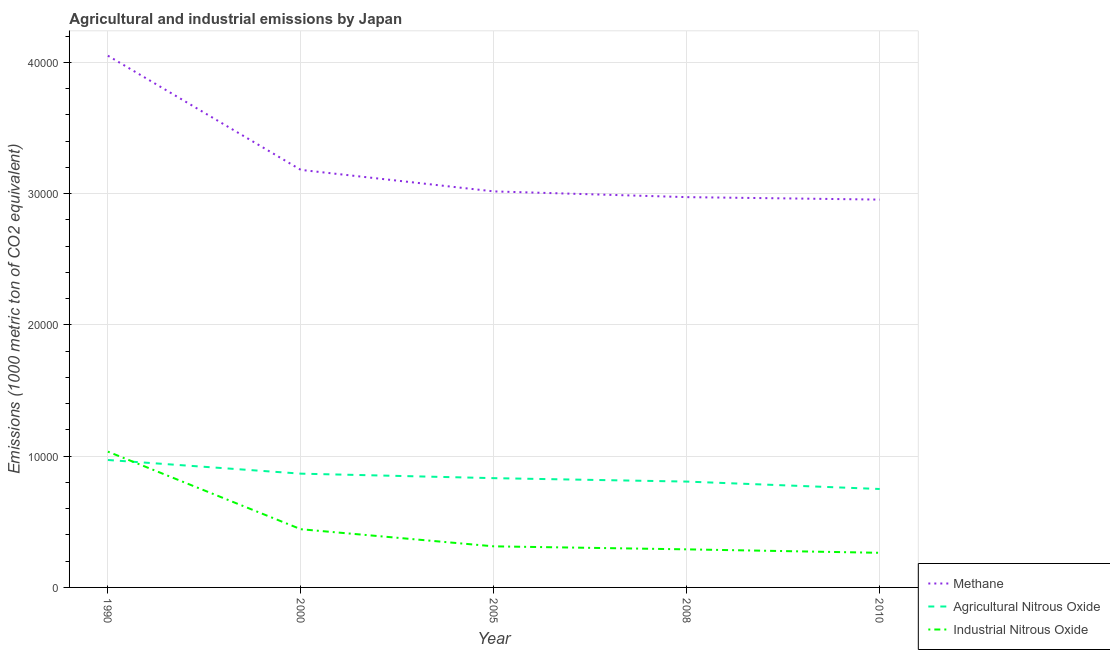How many different coloured lines are there?
Keep it short and to the point. 3. Is the number of lines equal to the number of legend labels?
Offer a very short reply. Yes. What is the amount of industrial nitrous oxide emissions in 2000?
Give a very brief answer. 4433.9. Across all years, what is the maximum amount of industrial nitrous oxide emissions?
Offer a very short reply. 1.03e+04. Across all years, what is the minimum amount of methane emissions?
Offer a terse response. 2.95e+04. In which year was the amount of industrial nitrous oxide emissions maximum?
Your answer should be very brief. 1990. In which year was the amount of industrial nitrous oxide emissions minimum?
Offer a terse response. 2010. What is the total amount of industrial nitrous oxide emissions in the graph?
Provide a short and direct response. 2.34e+04. What is the difference between the amount of agricultural nitrous oxide emissions in 2000 and that in 2008?
Your answer should be very brief. 603.5. What is the difference between the amount of industrial nitrous oxide emissions in 2010 and the amount of agricultural nitrous oxide emissions in 2005?
Ensure brevity in your answer.  -5687. What is the average amount of agricultural nitrous oxide emissions per year?
Give a very brief answer. 8452.46. In the year 2005, what is the difference between the amount of agricultural nitrous oxide emissions and amount of industrial nitrous oxide emissions?
Your response must be concise. 5194.4. In how many years, is the amount of agricultural nitrous oxide emissions greater than 14000 metric ton?
Provide a succinct answer. 0. What is the ratio of the amount of industrial nitrous oxide emissions in 1990 to that in 2000?
Offer a terse response. 2.33. Is the amount of agricultural nitrous oxide emissions in 1990 less than that in 2000?
Your answer should be compact. No. Is the difference between the amount of industrial nitrous oxide emissions in 2000 and 2010 greater than the difference between the amount of agricultural nitrous oxide emissions in 2000 and 2010?
Your answer should be very brief. Yes. What is the difference between the highest and the second highest amount of industrial nitrous oxide emissions?
Give a very brief answer. 5911.5. What is the difference between the highest and the lowest amount of industrial nitrous oxide emissions?
Keep it short and to the point. 7707.7. Is the sum of the amount of agricultural nitrous oxide emissions in 1990 and 2010 greater than the maximum amount of industrial nitrous oxide emissions across all years?
Offer a terse response. Yes. Does the amount of methane emissions monotonically increase over the years?
Give a very brief answer. No. Is the amount of industrial nitrous oxide emissions strictly less than the amount of agricultural nitrous oxide emissions over the years?
Provide a succinct answer. No. How many lines are there?
Offer a very short reply. 3. What is the difference between two consecutive major ticks on the Y-axis?
Keep it short and to the point. 10000. Does the graph contain grids?
Your response must be concise. Yes. Where does the legend appear in the graph?
Your answer should be compact. Bottom right. How many legend labels are there?
Offer a very short reply. 3. What is the title of the graph?
Provide a succinct answer. Agricultural and industrial emissions by Japan. Does "Spain" appear as one of the legend labels in the graph?
Your answer should be compact. No. What is the label or title of the Y-axis?
Offer a very short reply. Emissions (1000 metric ton of CO2 equivalent). What is the Emissions (1000 metric ton of CO2 equivalent) in Methane in 1990?
Give a very brief answer. 4.05e+04. What is the Emissions (1000 metric ton of CO2 equivalent) of Agricultural Nitrous Oxide in 1990?
Your answer should be very brief. 9708.8. What is the Emissions (1000 metric ton of CO2 equivalent) of Industrial Nitrous Oxide in 1990?
Your answer should be very brief. 1.03e+04. What is the Emissions (1000 metric ton of CO2 equivalent) in Methane in 2000?
Offer a very short reply. 3.18e+04. What is the Emissions (1000 metric ton of CO2 equivalent) in Agricultural Nitrous Oxide in 2000?
Provide a succinct answer. 8667.2. What is the Emissions (1000 metric ton of CO2 equivalent) of Industrial Nitrous Oxide in 2000?
Offer a very short reply. 4433.9. What is the Emissions (1000 metric ton of CO2 equivalent) in Methane in 2005?
Offer a very short reply. 3.02e+04. What is the Emissions (1000 metric ton of CO2 equivalent) in Agricultural Nitrous Oxide in 2005?
Your answer should be compact. 8324.7. What is the Emissions (1000 metric ton of CO2 equivalent) in Industrial Nitrous Oxide in 2005?
Provide a short and direct response. 3130.3. What is the Emissions (1000 metric ton of CO2 equivalent) in Methane in 2008?
Your answer should be compact. 2.97e+04. What is the Emissions (1000 metric ton of CO2 equivalent) of Agricultural Nitrous Oxide in 2008?
Offer a very short reply. 8063.7. What is the Emissions (1000 metric ton of CO2 equivalent) in Industrial Nitrous Oxide in 2008?
Your answer should be very brief. 2901. What is the Emissions (1000 metric ton of CO2 equivalent) in Methane in 2010?
Your response must be concise. 2.95e+04. What is the Emissions (1000 metric ton of CO2 equivalent) in Agricultural Nitrous Oxide in 2010?
Your answer should be very brief. 7497.9. What is the Emissions (1000 metric ton of CO2 equivalent) of Industrial Nitrous Oxide in 2010?
Provide a succinct answer. 2637.7. Across all years, what is the maximum Emissions (1000 metric ton of CO2 equivalent) in Methane?
Provide a short and direct response. 4.05e+04. Across all years, what is the maximum Emissions (1000 metric ton of CO2 equivalent) in Agricultural Nitrous Oxide?
Give a very brief answer. 9708.8. Across all years, what is the maximum Emissions (1000 metric ton of CO2 equivalent) of Industrial Nitrous Oxide?
Offer a terse response. 1.03e+04. Across all years, what is the minimum Emissions (1000 metric ton of CO2 equivalent) of Methane?
Make the answer very short. 2.95e+04. Across all years, what is the minimum Emissions (1000 metric ton of CO2 equivalent) of Agricultural Nitrous Oxide?
Your answer should be very brief. 7497.9. Across all years, what is the minimum Emissions (1000 metric ton of CO2 equivalent) in Industrial Nitrous Oxide?
Your response must be concise. 2637.7. What is the total Emissions (1000 metric ton of CO2 equivalent) in Methane in the graph?
Ensure brevity in your answer.  1.62e+05. What is the total Emissions (1000 metric ton of CO2 equivalent) of Agricultural Nitrous Oxide in the graph?
Your answer should be very brief. 4.23e+04. What is the total Emissions (1000 metric ton of CO2 equivalent) of Industrial Nitrous Oxide in the graph?
Your response must be concise. 2.34e+04. What is the difference between the Emissions (1000 metric ton of CO2 equivalent) in Methane in 1990 and that in 2000?
Your answer should be compact. 8700.7. What is the difference between the Emissions (1000 metric ton of CO2 equivalent) in Agricultural Nitrous Oxide in 1990 and that in 2000?
Ensure brevity in your answer.  1041.6. What is the difference between the Emissions (1000 metric ton of CO2 equivalent) of Industrial Nitrous Oxide in 1990 and that in 2000?
Offer a very short reply. 5911.5. What is the difference between the Emissions (1000 metric ton of CO2 equivalent) of Methane in 1990 and that in 2005?
Provide a short and direct response. 1.03e+04. What is the difference between the Emissions (1000 metric ton of CO2 equivalent) of Agricultural Nitrous Oxide in 1990 and that in 2005?
Your answer should be very brief. 1384.1. What is the difference between the Emissions (1000 metric ton of CO2 equivalent) of Industrial Nitrous Oxide in 1990 and that in 2005?
Ensure brevity in your answer.  7215.1. What is the difference between the Emissions (1000 metric ton of CO2 equivalent) of Methane in 1990 and that in 2008?
Provide a short and direct response. 1.08e+04. What is the difference between the Emissions (1000 metric ton of CO2 equivalent) in Agricultural Nitrous Oxide in 1990 and that in 2008?
Offer a terse response. 1645.1. What is the difference between the Emissions (1000 metric ton of CO2 equivalent) in Industrial Nitrous Oxide in 1990 and that in 2008?
Your response must be concise. 7444.4. What is the difference between the Emissions (1000 metric ton of CO2 equivalent) of Methane in 1990 and that in 2010?
Keep it short and to the point. 1.10e+04. What is the difference between the Emissions (1000 metric ton of CO2 equivalent) of Agricultural Nitrous Oxide in 1990 and that in 2010?
Your answer should be compact. 2210.9. What is the difference between the Emissions (1000 metric ton of CO2 equivalent) in Industrial Nitrous Oxide in 1990 and that in 2010?
Ensure brevity in your answer.  7707.7. What is the difference between the Emissions (1000 metric ton of CO2 equivalent) of Methane in 2000 and that in 2005?
Your answer should be compact. 1638. What is the difference between the Emissions (1000 metric ton of CO2 equivalent) of Agricultural Nitrous Oxide in 2000 and that in 2005?
Provide a short and direct response. 342.5. What is the difference between the Emissions (1000 metric ton of CO2 equivalent) of Industrial Nitrous Oxide in 2000 and that in 2005?
Keep it short and to the point. 1303.6. What is the difference between the Emissions (1000 metric ton of CO2 equivalent) in Methane in 2000 and that in 2008?
Your answer should be compact. 2075.3. What is the difference between the Emissions (1000 metric ton of CO2 equivalent) of Agricultural Nitrous Oxide in 2000 and that in 2008?
Offer a very short reply. 603.5. What is the difference between the Emissions (1000 metric ton of CO2 equivalent) in Industrial Nitrous Oxide in 2000 and that in 2008?
Provide a short and direct response. 1532.9. What is the difference between the Emissions (1000 metric ton of CO2 equivalent) of Methane in 2000 and that in 2010?
Your response must be concise. 2263.3. What is the difference between the Emissions (1000 metric ton of CO2 equivalent) in Agricultural Nitrous Oxide in 2000 and that in 2010?
Provide a short and direct response. 1169.3. What is the difference between the Emissions (1000 metric ton of CO2 equivalent) in Industrial Nitrous Oxide in 2000 and that in 2010?
Provide a short and direct response. 1796.2. What is the difference between the Emissions (1000 metric ton of CO2 equivalent) in Methane in 2005 and that in 2008?
Provide a short and direct response. 437.3. What is the difference between the Emissions (1000 metric ton of CO2 equivalent) of Agricultural Nitrous Oxide in 2005 and that in 2008?
Provide a succinct answer. 261. What is the difference between the Emissions (1000 metric ton of CO2 equivalent) of Industrial Nitrous Oxide in 2005 and that in 2008?
Provide a short and direct response. 229.3. What is the difference between the Emissions (1000 metric ton of CO2 equivalent) of Methane in 2005 and that in 2010?
Keep it short and to the point. 625.3. What is the difference between the Emissions (1000 metric ton of CO2 equivalent) of Agricultural Nitrous Oxide in 2005 and that in 2010?
Your response must be concise. 826.8. What is the difference between the Emissions (1000 metric ton of CO2 equivalent) of Industrial Nitrous Oxide in 2005 and that in 2010?
Provide a succinct answer. 492.6. What is the difference between the Emissions (1000 metric ton of CO2 equivalent) of Methane in 2008 and that in 2010?
Offer a very short reply. 188. What is the difference between the Emissions (1000 metric ton of CO2 equivalent) of Agricultural Nitrous Oxide in 2008 and that in 2010?
Ensure brevity in your answer.  565.8. What is the difference between the Emissions (1000 metric ton of CO2 equivalent) of Industrial Nitrous Oxide in 2008 and that in 2010?
Offer a terse response. 263.3. What is the difference between the Emissions (1000 metric ton of CO2 equivalent) of Methane in 1990 and the Emissions (1000 metric ton of CO2 equivalent) of Agricultural Nitrous Oxide in 2000?
Ensure brevity in your answer.  3.18e+04. What is the difference between the Emissions (1000 metric ton of CO2 equivalent) in Methane in 1990 and the Emissions (1000 metric ton of CO2 equivalent) in Industrial Nitrous Oxide in 2000?
Make the answer very short. 3.61e+04. What is the difference between the Emissions (1000 metric ton of CO2 equivalent) in Agricultural Nitrous Oxide in 1990 and the Emissions (1000 metric ton of CO2 equivalent) in Industrial Nitrous Oxide in 2000?
Your answer should be compact. 5274.9. What is the difference between the Emissions (1000 metric ton of CO2 equivalent) of Methane in 1990 and the Emissions (1000 metric ton of CO2 equivalent) of Agricultural Nitrous Oxide in 2005?
Ensure brevity in your answer.  3.22e+04. What is the difference between the Emissions (1000 metric ton of CO2 equivalent) of Methane in 1990 and the Emissions (1000 metric ton of CO2 equivalent) of Industrial Nitrous Oxide in 2005?
Ensure brevity in your answer.  3.74e+04. What is the difference between the Emissions (1000 metric ton of CO2 equivalent) of Agricultural Nitrous Oxide in 1990 and the Emissions (1000 metric ton of CO2 equivalent) of Industrial Nitrous Oxide in 2005?
Your answer should be very brief. 6578.5. What is the difference between the Emissions (1000 metric ton of CO2 equivalent) of Methane in 1990 and the Emissions (1000 metric ton of CO2 equivalent) of Agricultural Nitrous Oxide in 2008?
Give a very brief answer. 3.24e+04. What is the difference between the Emissions (1000 metric ton of CO2 equivalent) in Methane in 1990 and the Emissions (1000 metric ton of CO2 equivalent) in Industrial Nitrous Oxide in 2008?
Offer a very short reply. 3.76e+04. What is the difference between the Emissions (1000 metric ton of CO2 equivalent) of Agricultural Nitrous Oxide in 1990 and the Emissions (1000 metric ton of CO2 equivalent) of Industrial Nitrous Oxide in 2008?
Ensure brevity in your answer.  6807.8. What is the difference between the Emissions (1000 metric ton of CO2 equivalent) in Methane in 1990 and the Emissions (1000 metric ton of CO2 equivalent) in Agricultural Nitrous Oxide in 2010?
Your answer should be compact. 3.30e+04. What is the difference between the Emissions (1000 metric ton of CO2 equivalent) in Methane in 1990 and the Emissions (1000 metric ton of CO2 equivalent) in Industrial Nitrous Oxide in 2010?
Your response must be concise. 3.79e+04. What is the difference between the Emissions (1000 metric ton of CO2 equivalent) of Agricultural Nitrous Oxide in 1990 and the Emissions (1000 metric ton of CO2 equivalent) of Industrial Nitrous Oxide in 2010?
Provide a short and direct response. 7071.1. What is the difference between the Emissions (1000 metric ton of CO2 equivalent) of Methane in 2000 and the Emissions (1000 metric ton of CO2 equivalent) of Agricultural Nitrous Oxide in 2005?
Offer a very short reply. 2.35e+04. What is the difference between the Emissions (1000 metric ton of CO2 equivalent) in Methane in 2000 and the Emissions (1000 metric ton of CO2 equivalent) in Industrial Nitrous Oxide in 2005?
Give a very brief answer. 2.87e+04. What is the difference between the Emissions (1000 metric ton of CO2 equivalent) of Agricultural Nitrous Oxide in 2000 and the Emissions (1000 metric ton of CO2 equivalent) of Industrial Nitrous Oxide in 2005?
Keep it short and to the point. 5536.9. What is the difference between the Emissions (1000 metric ton of CO2 equivalent) in Methane in 2000 and the Emissions (1000 metric ton of CO2 equivalent) in Agricultural Nitrous Oxide in 2008?
Ensure brevity in your answer.  2.37e+04. What is the difference between the Emissions (1000 metric ton of CO2 equivalent) of Methane in 2000 and the Emissions (1000 metric ton of CO2 equivalent) of Industrial Nitrous Oxide in 2008?
Provide a succinct answer. 2.89e+04. What is the difference between the Emissions (1000 metric ton of CO2 equivalent) of Agricultural Nitrous Oxide in 2000 and the Emissions (1000 metric ton of CO2 equivalent) of Industrial Nitrous Oxide in 2008?
Ensure brevity in your answer.  5766.2. What is the difference between the Emissions (1000 metric ton of CO2 equivalent) of Methane in 2000 and the Emissions (1000 metric ton of CO2 equivalent) of Agricultural Nitrous Oxide in 2010?
Your answer should be very brief. 2.43e+04. What is the difference between the Emissions (1000 metric ton of CO2 equivalent) in Methane in 2000 and the Emissions (1000 metric ton of CO2 equivalent) in Industrial Nitrous Oxide in 2010?
Offer a very short reply. 2.92e+04. What is the difference between the Emissions (1000 metric ton of CO2 equivalent) in Agricultural Nitrous Oxide in 2000 and the Emissions (1000 metric ton of CO2 equivalent) in Industrial Nitrous Oxide in 2010?
Offer a terse response. 6029.5. What is the difference between the Emissions (1000 metric ton of CO2 equivalent) of Methane in 2005 and the Emissions (1000 metric ton of CO2 equivalent) of Agricultural Nitrous Oxide in 2008?
Ensure brevity in your answer.  2.21e+04. What is the difference between the Emissions (1000 metric ton of CO2 equivalent) in Methane in 2005 and the Emissions (1000 metric ton of CO2 equivalent) in Industrial Nitrous Oxide in 2008?
Your answer should be compact. 2.73e+04. What is the difference between the Emissions (1000 metric ton of CO2 equivalent) of Agricultural Nitrous Oxide in 2005 and the Emissions (1000 metric ton of CO2 equivalent) of Industrial Nitrous Oxide in 2008?
Offer a very short reply. 5423.7. What is the difference between the Emissions (1000 metric ton of CO2 equivalent) of Methane in 2005 and the Emissions (1000 metric ton of CO2 equivalent) of Agricultural Nitrous Oxide in 2010?
Your response must be concise. 2.27e+04. What is the difference between the Emissions (1000 metric ton of CO2 equivalent) in Methane in 2005 and the Emissions (1000 metric ton of CO2 equivalent) in Industrial Nitrous Oxide in 2010?
Provide a succinct answer. 2.75e+04. What is the difference between the Emissions (1000 metric ton of CO2 equivalent) in Agricultural Nitrous Oxide in 2005 and the Emissions (1000 metric ton of CO2 equivalent) in Industrial Nitrous Oxide in 2010?
Offer a terse response. 5687. What is the difference between the Emissions (1000 metric ton of CO2 equivalent) of Methane in 2008 and the Emissions (1000 metric ton of CO2 equivalent) of Agricultural Nitrous Oxide in 2010?
Ensure brevity in your answer.  2.22e+04. What is the difference between the Emissions (1000 metric ton of CO2 equivalent) of Methane in 2008 and the Emissions (1000 metric ton of CO2 equivalent) of Industrial Nitrous Oxide in 2010?
Ensure brevity in your answer.  2.71e+04. What is the difference between the Emissions (1000 metric ton of CO2 equivalent) in Agricultural Nitrous Oxide in 2008 and the Emissions (1000 metric ton of CO2 equivalent) in Industrial Nitrous Oxide in 2010?
Your answer should be compact. 5426. What is the average Emissions (1000 metric ton of CO2 equivalent) of Methane per year?
Ensure brevity in your answer.  3.24e+04. What is the average Emissions (1000 metric ton of CO2 equivalent) in Agricultural Nitrous Oxide per year?
Offer a terse response. 8452.46. What is the average Emissions (1000 metric ton of CO2 equivalent) of Industrial Nitrous Oxide per year?
Your answer should be compact. 4689.66. In the year 1990, what is the difference between the Emissions (1000 metric ton of CO2 equivalent) of Methane and Emissions (1000 metric ton of CO2 equivalent) of Agricultural Nitrous Oxide?
Keep it short and to the point. 3.08e+04. In the year 1990, what is the difference between the Emissions (1000 metric ton of CO2 equivalent) of Methane and Emissions (1000 metric ton of CO2 equivalent) of Industrial Nitrous Oxide?
Your answer should be very brief. 3.02e+04. In the year 1990, what is the difference between the Emissions (1000 metric ton of CO2 equivalent) in Agricultural Nitrous Oxide and Emissions (1000 metric ton of CO2 equivalent) in Industrial Nitrous Oxide?
Provide a succinct answer. -636.6. In the year 2000, what is the difference between the Emissions (1000 metric ton of CO2 equivalent) of Methane and Emissions (1000 metric ton of CO2 equivalent) of Agricultural Nitrous Oxide?
Ensure brevity in your answer.  2.31e+04. In the year 2000, what is the difference between the Emissions (1000 metric ton of CO2 equivalent) in Methane and Emissions (1000 metric ton of CO2 equivalent) in Industrial Nitrous Oxide?
Make the answer very short. 2.74e+04. In the year 2000, what is the difference between the Emissions (1000 metric ton of CO2 equivalent) of Agricultural Nitrous Oxide and Emissions (1000 metric ton of CO2 equivalent) of Industrial Nitrous Oxide?
Provide a succinct answer. 4233.3. In the year 2005, what is the difference between the Emissions (1000 metric ton of CO2 equivalent) in Methane and Emissions (1000 metric ton of CO2 equivalent) in Agricultural Nitrous Oxide?
Make the answer very short. 2.18e+04. In the year 2005, what is the difference between the Emissions (1000 metric ton of CO2 equivalent) in Methane and Emissions (1000 metric ton of CO2 equivalent) in Industrial Nitrous Oxide?
Your response must be concise. 2.70e+04. In the year 2005, what is the difference between the Emissions (1000 metric ton of CO2 equivalent) in Agricultural Nitrous Oxide and Emissions (1000 metric ton of CO2 equivalent) in Industrial Nitrous Oxide?
Provide a succinct answer. 5194.4. In the year 2008, what is the difference between the Emissions (1000 metric ton of CO2 equivalent) in Methane and Emissions (1000 metric ton of CO2 equivalent) in Agricultural Nitrous Oxide?
Ensure brevity in your answer.  2.17e+04. In the year 2008, what is the difference between the Emissions (1000 metric ton of CO2 equivalent) of Methane and Emissions (1000 metric ton of CO2 equivalent) of Industrial Nitrous Oxide?
Ensure brevity in your answer.  2.68e+04. In the year 2008, what is the difference between the Emissions (1000 metric ton of CO2 equivalent) in Agricultural Nitrous Oxide and Emissions (1000 metric ton of CO2 equivalent) in Industrial Nitrous Oxide?
Ensure brevity in your answer.  5162.7. In the year 2010, what is the difference between the Emissions (1000 metric ton of CO2 equivalent) of Methane and Emissions (1000 metric ton of CO2 equivalent) of Agricultural Nitrous Oxide?
Offer a very short reply. 2.20e+04. In the year 2010, what is the difference between the Emissions (1000 metric ton of CO2 equivalent) of Methane and Emissions (1000 metric ton of CO2 equivalent) of Industrial Nitrous Oxide?
Offer a terse response. 2.69e+04. In the year 2010, what is the difference between the Emissions (1000 metric ton of CO2 equivalent) in Agricultural Nitrous Oxide and Emissions (1000 metric ton of CO2 equivalent) in Industrial Nitrous Oxide?
Provide a short and direct response. 4860.2. What is the ratio of the Emissions (1000 metric ton of CO2 equivalent) of Methane in 1990 to that in 2000?
Provide a short and direct response. 1.27. What is the ratio of the Emissions (1000 metric ton of CO2 equivalent) of Agricultural Nitrous Oxide in 1990 to that in 2000?
Provide a short and direct response. 1.12. What is the ratio of the Emissions (1000 metric ton of CO2 equivalent) of Industrial Nitrous Oxide in 1990 to that in 2000?
Your answer should be compact. 2.33. What is the ratio of the Emissions (1000 metric ton of CO2 equivalent) of Methane in 1990 to that in 2005?
Make the answer very short. 1.34. What is the ratio of the Emissions (1000 metric ton of CO2 equivalent) in Agricultural Nitrous Oxide in 1990 to that in 2005?
Your answer should be compact. 1.17. What is the ratio of the Emissions (1000 metric ton of CO2 equivalent) of Industrial Nitrous Oxide in 1990 to that in 2005?
Make the answer very short. 3.3. What is the ratio of the Emissions (1000 metric ton of CO2 equivalent) in Methane in 1990 to that in 2008?
Offer a very short reply. 1.36. What is the ratio of the Emissions (1000 metric ton of CO2 equivalent) of Agricultural Nitrous Oxide in 1990 to that in 2008?
Make the answer very short. 1.2. What is the ratio of the Emissions (1000 metric ton of CO2 equivalent) of Industrial Nitrous Oxide in 1990 to that in 2008?
Make the answer very short. 3.57. What is the ratio of the Emissions (1000 metric ton of CO2 equivalent) of Methane in 1990 to that in 2010?
Make the answer very short. 1.37. What is the ratio of the Emissions (1000 metric ton of CO2 equivalent) of Agricultural Nitrous Oxide in 1990 to that in 2010?
Keep it short and to the point. 1.29. What is the ratio of the Emissions (1000 metric ton of CO2 equivalent) in Industrial Nitrous Oxide in 1990 to that in 2010?
Make the answer very short. 3.92. What is the ratio of the Emissions (1000 metric ton of CO2 equivalent) in Methane in 2000 to that in 2005?
Provide a succinct answer. 1.05. What is the ratio of the Emissions (1000 metric ton of CO2 equivalent) of Agricultural Nitrous Oxide in 2000 to that in 2005?
Make the answer very short. 1.04. What is the ratio of the Emissions (1000 metric ton of CO2 equivalent) in Industrial Nitrous Oxide in 2000 to that in 2005?
Give a very brief answer. 1.42. What is the ratio of the Emissions (1000 metric ton of CO2 equivalent) of Methane in 2000 to that in 2008?
Provide a succinct answer. 1.07. What is the ratio of the Emissions (1000 metric ton of CO2 equivalent) in Agricultural Nitrous Oxide in 2000 to that in 2008?
Your answer should be very brief. 1.07. What is the ratio of the Emissions (1000 metric ton of CO2 equivalent) of Industrial Nitrous Oxide in 2000 to that in 2008?
Keep it short and to the point. 1.53. What is the ratio of the Emissions (1000 metric ton of CO2 equivalent) of Methane in 2000 to that in 2010?
Ensure brevity in your answer.  1.08. What is the ratio of the Emissions (1000 metric ton of CO2 equivalent) of Agricultural Nitrous Oxide in 2000 to that in 2010?
Make the answer very short. 1.16. What is the ratio of the Emissions (1000 metric ton of CO2 equivalent) of Industrial Nitrous Oxide in 2000 to that in 2010?
Your answer should be very brief. 1.68. What is the ratio of the Emissions (1000 metric ton of CO2 equivalent) of Methane in 2005 to that in 2008?
Your answer should be very brief. 1.01. What is the ratio of the Emissions (1000 metric ton of CO2 equivalent) in Agricultural Nitrous Oxide in 2005 to that in 2008?
Provide a succinct answer. 1.03. What is the ratio of the Emissions (1000 metric ton of CO2 equivalent) in Industrial Nitrous Oxide in 2005 to that in 2008?
Your response must be concise. 1.08. What is the ratio of the Emissions (1000 metric ton of CO2 equivalent) in Methane in 2005 to that in 2010?
Make the answer very short. 1.02. What is the ratio of the Emissions (1000 metric ton of CO2 equivalent) of Agricultural Nitrous Oxide in 2005 to that in 2010?
Your answer should be very brief. 1.11. What is the ratio of the Emissions (1000 metric ton of CO2 equivalent) of Industrial Nitrous Oxide in 2005 to that in 2010?
Ensure brevity in your answer.  1.19. What is the ratio of the Emissions (1000 metric ton of CO2 equivalent) of Methane in 2008 to that in 2010?
Offer a terse response. 1.01. What is the ratio of the Emissions (1000 metric ton of CO2 equivalent) in Agricultural Nitrous Oxide in 2008 to that in 2010?
Keep it short and to the point. 1.08. What is the ratio of the Emissions (1000 metric ton of CO2 equivalent) in Industrial Nitrous Oxide in 2008 to that in 2010?
Offer a very short reply. 1.1. What is the difference between the highest and the second highest Emissions (1000 metric ton of CO2 equivalent) in Methane?
Provide a succinct answer. 8700.7. What is the difference between the highest and the second highest Emissions (1000 metric ton of CO2 equivalent) in Agricultural Nitrous Oxide?
Ensure brevity in your answer.  1041.6. What is the difference between the highest and the second highest Emissions (1000 metric ton of CO2 equivalent) of Industrial Nitrous Oxide?
Keep it short and to the point. 5911.5. What is the difference between the highest and the lowest Emissions (1000 metric ton of CO2 equivalent) of Methane?
Provide a succinct answer. 1.10e+04. What is the difference between the highest and the lowest Emissions (1000 metric ton of CO2 equivalent) of Agricultural Nitrous Oxide?
Your response must be concise. 2210.9. What is the difference between the highest and the lowest Emissions (1000 metric ton of CO2 equivalent) of Industrial Nitrous Oxide?
Your answer should be very brief. 7707.7. 